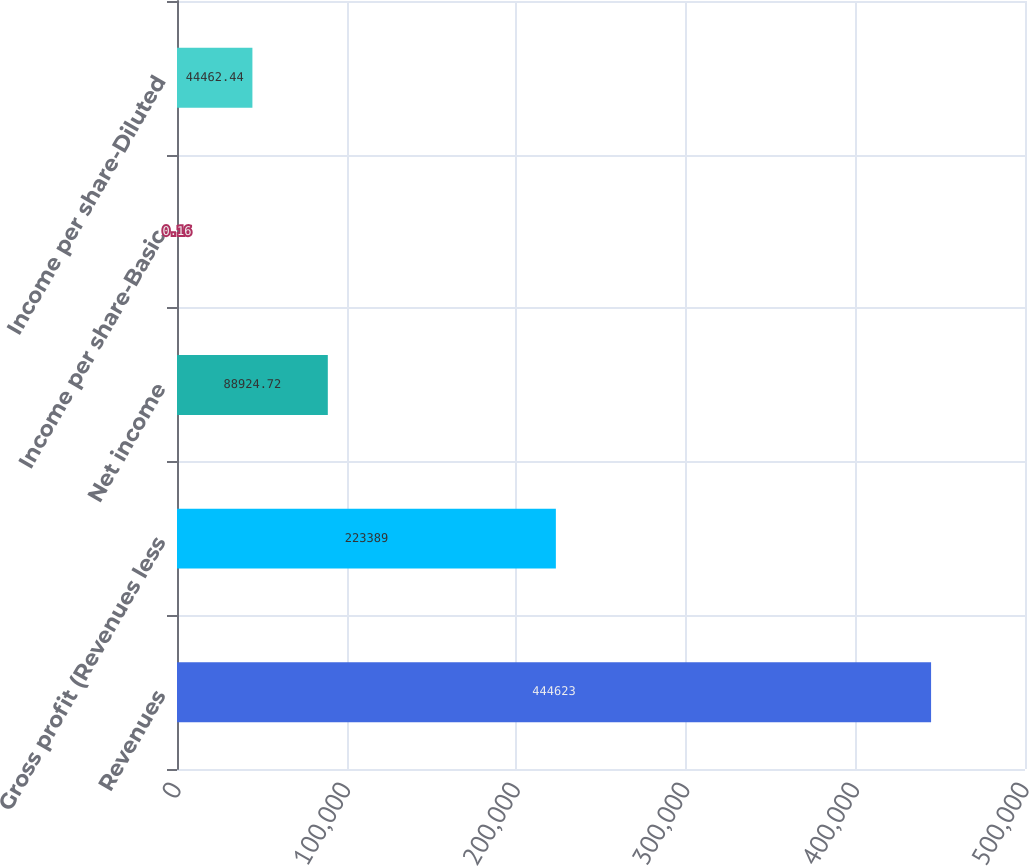Convert chart. <chart><loc_0><loc_0><loc_500><loc_500><bar_chart><fcel>Revenues<fcel>Gross profit (Revenues less<fcel>Net income<fcel>Income per share-Basic<fcel>Income per share-Diluted<nl><fcel>444623<fcel>223389<fcel>88924.7<fcel>0.16<fcel>44462.4<nl></chart> 